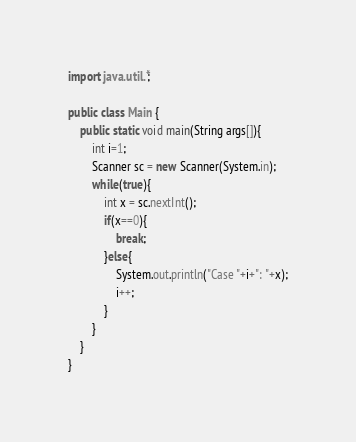<code> <loc_0><loc_0><loc_500><loc_500><_Java_>import java.util.*;

public class Main {
	public static void main(String args[]){
		int i=1;
		Scanner sc = new Scanner(System.in);
		while(true){
			int x = sc.nextInt();
			if(x==0){
				break;
			}else{
				System.out.println("Case "+i+": "+x);
				i++;
			}
		}
	}
}</code> 